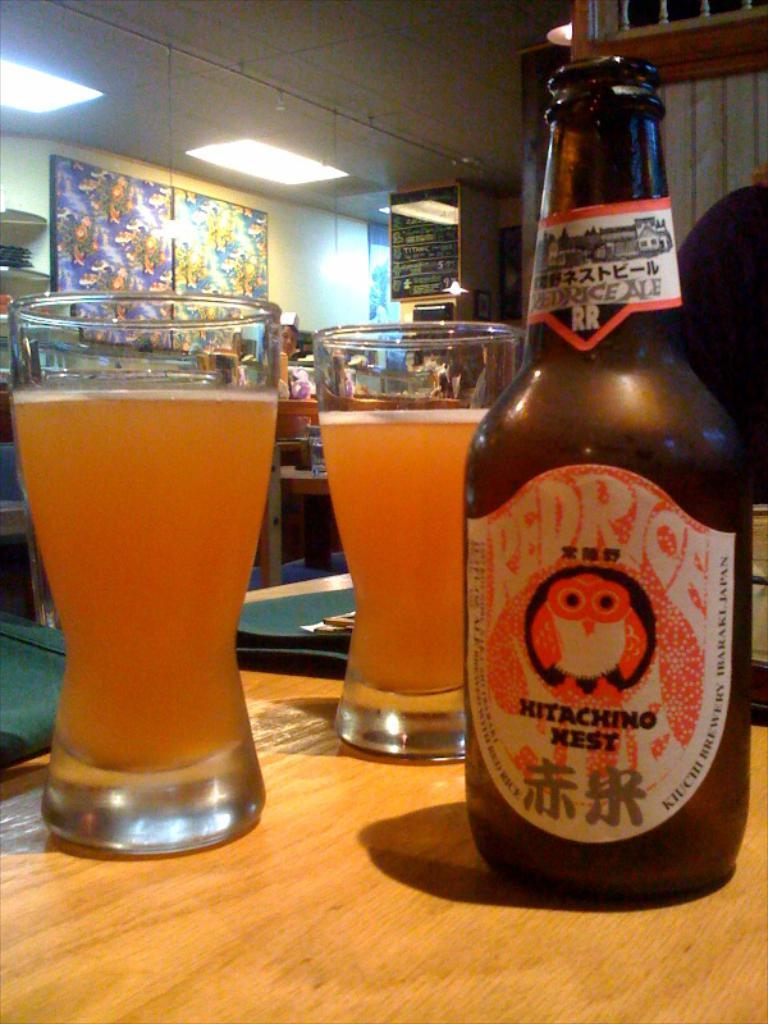<image>
Share a concise interpretation of the image provided. A bottle of Red Rice beer sits in two glasses on a table 